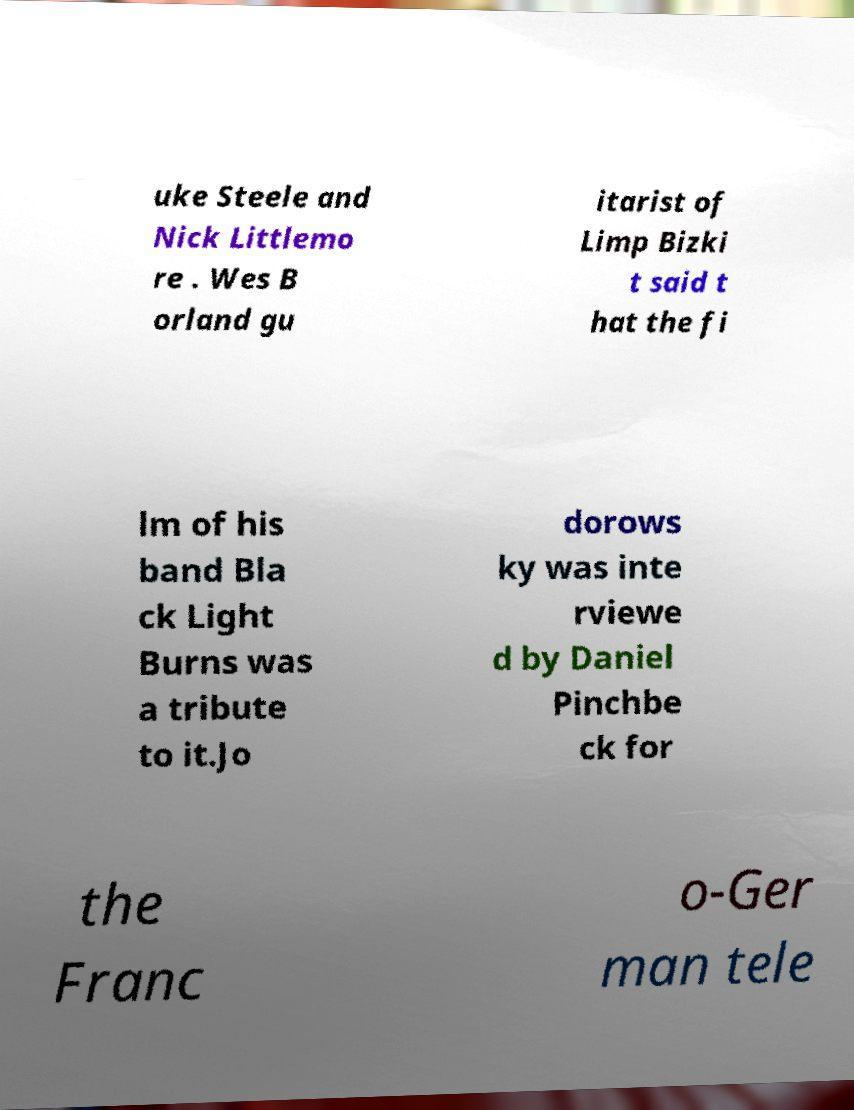Please read and relay the text visible in this image. What does it say? uke Steele and Nick Littlemo re . Wes B orland gu itarist of Limp Bizki t said t hat the fi lm of his band Bla ck Light Burns was a tribute to it.Jo dorows ky was inte rviewe d by Daniel Pinchbe ck for the Franc o-Ger man tele 